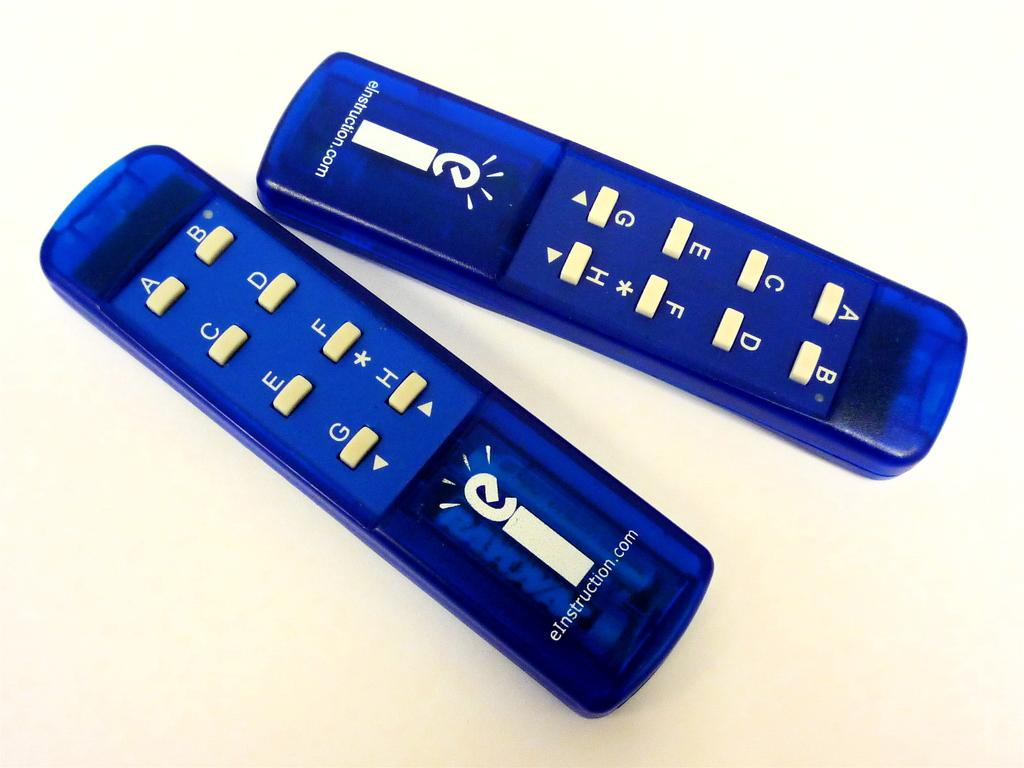Provide a one-sentence caption for the provided image. The blue remote is from eInstruction and is used to answer multiple choice questions in class. 